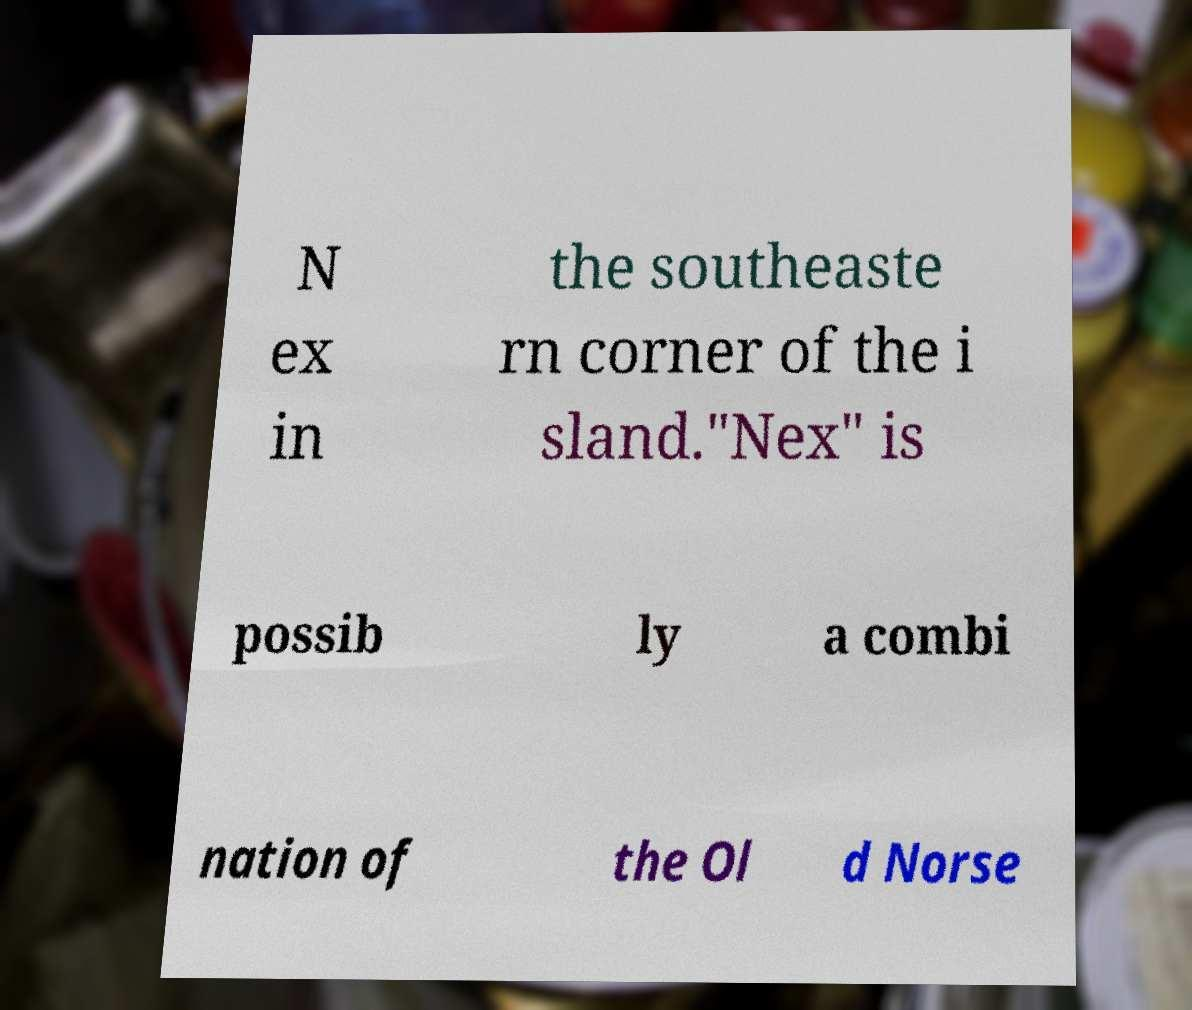Could you extract and type out the text from this image? N ex in the southeaste rn corner of the i sland."Nex" is possib ly a combi nation of the Ol d Norse 